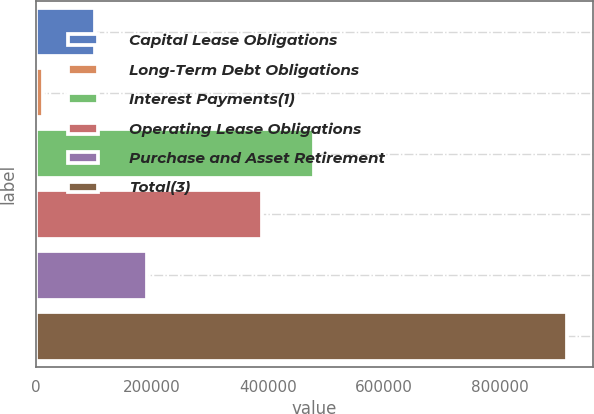Convert chart to OTSL. <chart><loc_0><loc_0><loc_500><loc_500><bar_chart><fcel>Capital Lease Obligations<fcel>Long-Term Debt Obligations<fcel>Interest Payments(1)<fcel>Operating Lease Obligations<fcel>Purchase and Asset Retirement<fcel>Total(3)<nl><fcel>102247<fcel>11858<fcel>480222<fcel>389833<fcel>192636<fcel>915748<nl></chart> 